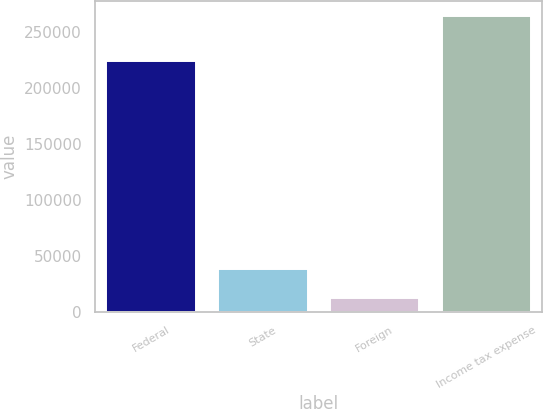<chart> <loc_0><loc_0><loc_500><loc_500><bar_chart><fcel>Federal<fcel>State<fcel>Foreign<fcel>Income tax expense<nl><fcel>223837<fcel>37840.8<fcel>12634<fcel>264702<nl></chart> 